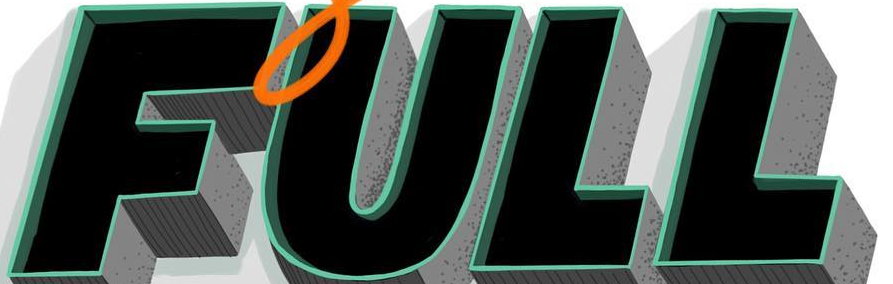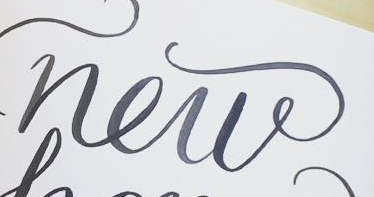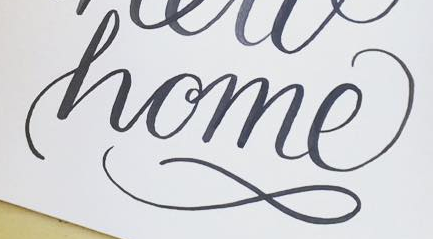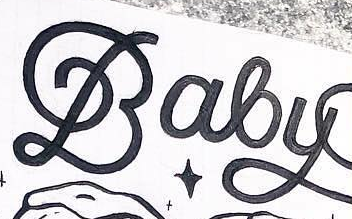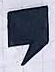Read the text content from these images in order, separated by a semicolon. FULL; new; home; Baby; , 